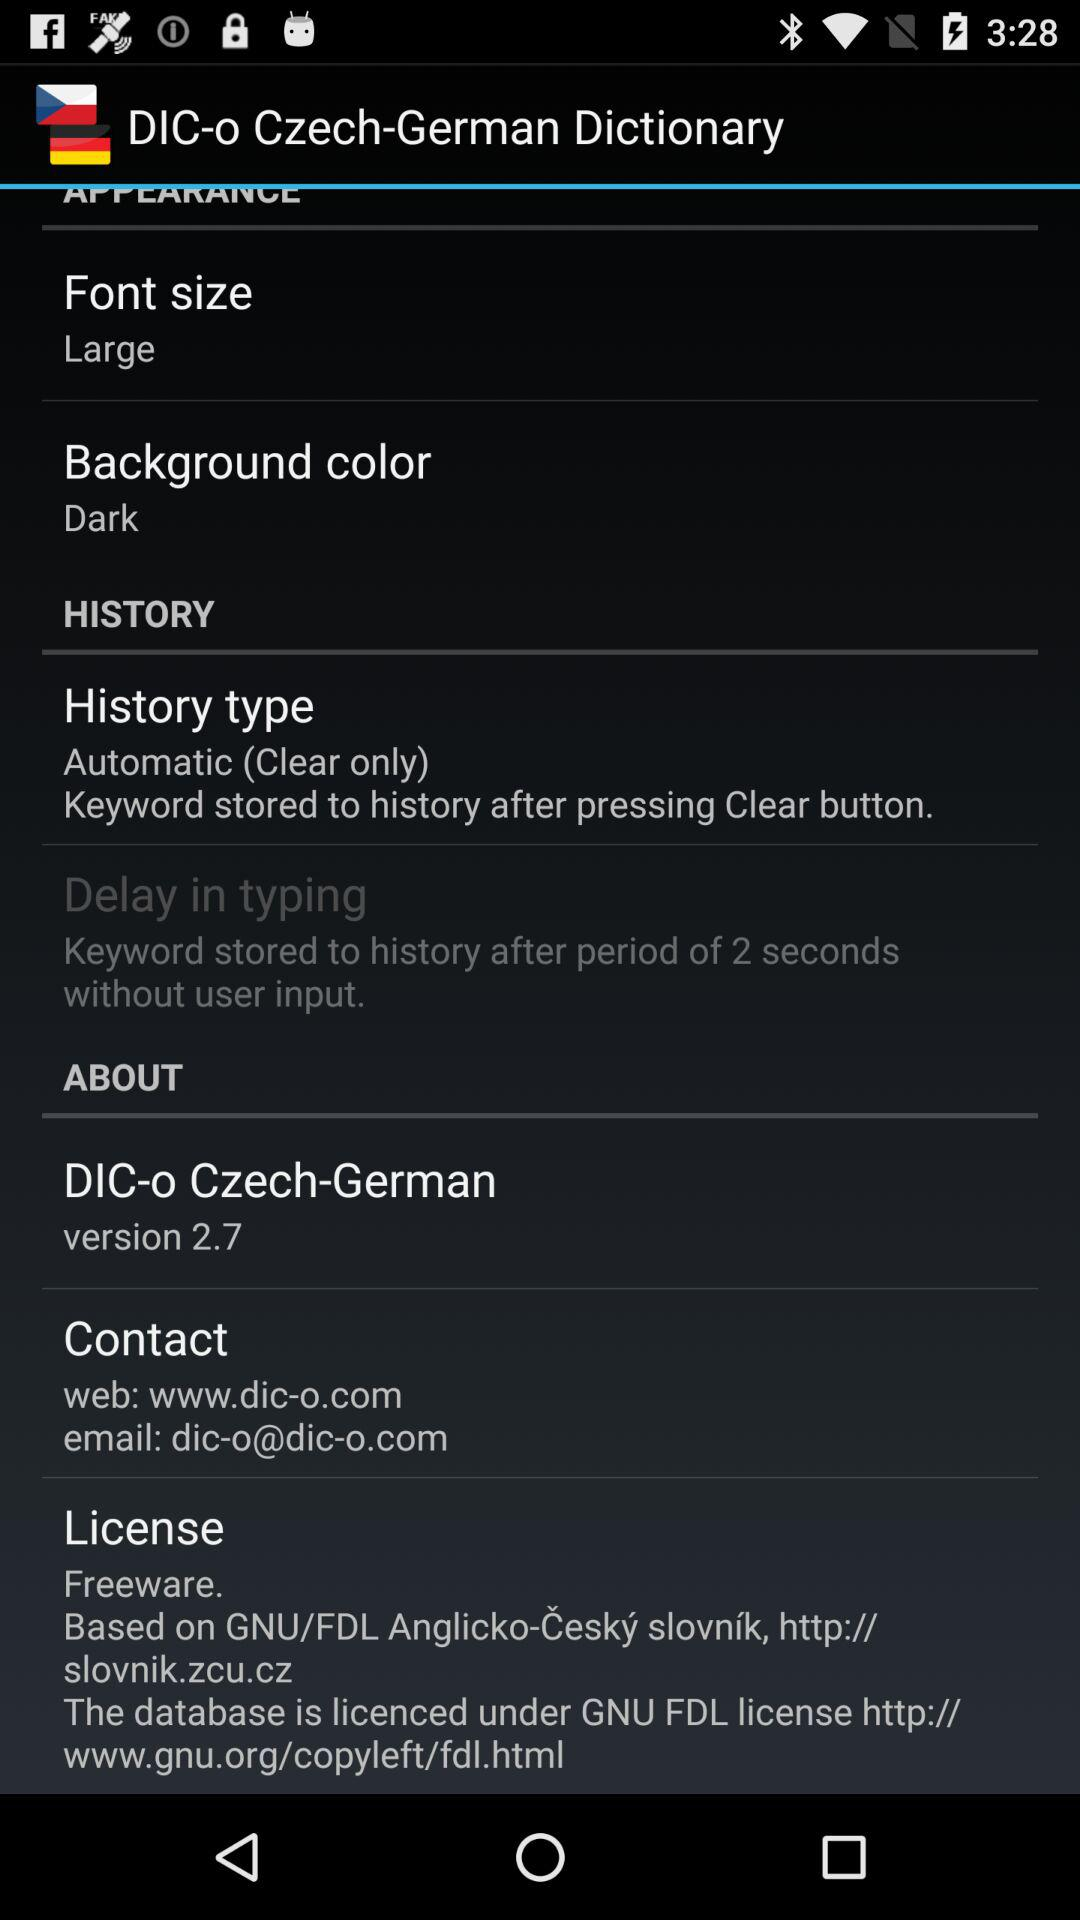What is the "History type"? The "History type" is "Automatic". 